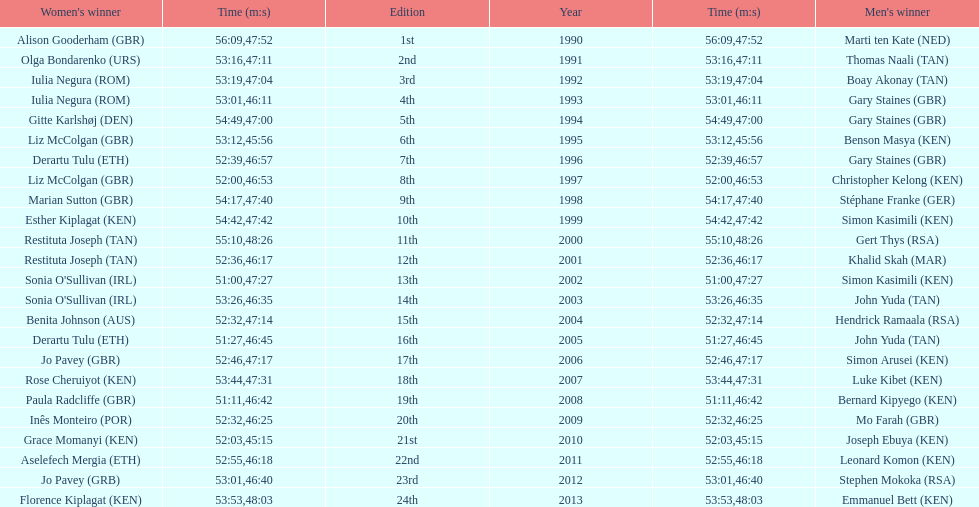How long did sonia o'sullivan take to finish in 2003? 53:26. 